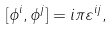Convert formula to latex. <formula><loc_0><loc_0><loc_500><loc_500>[ \phi ^ { i } , \phi ^ { j } ] = i \pi \varepsilon ^ { i j } ,</formula> 